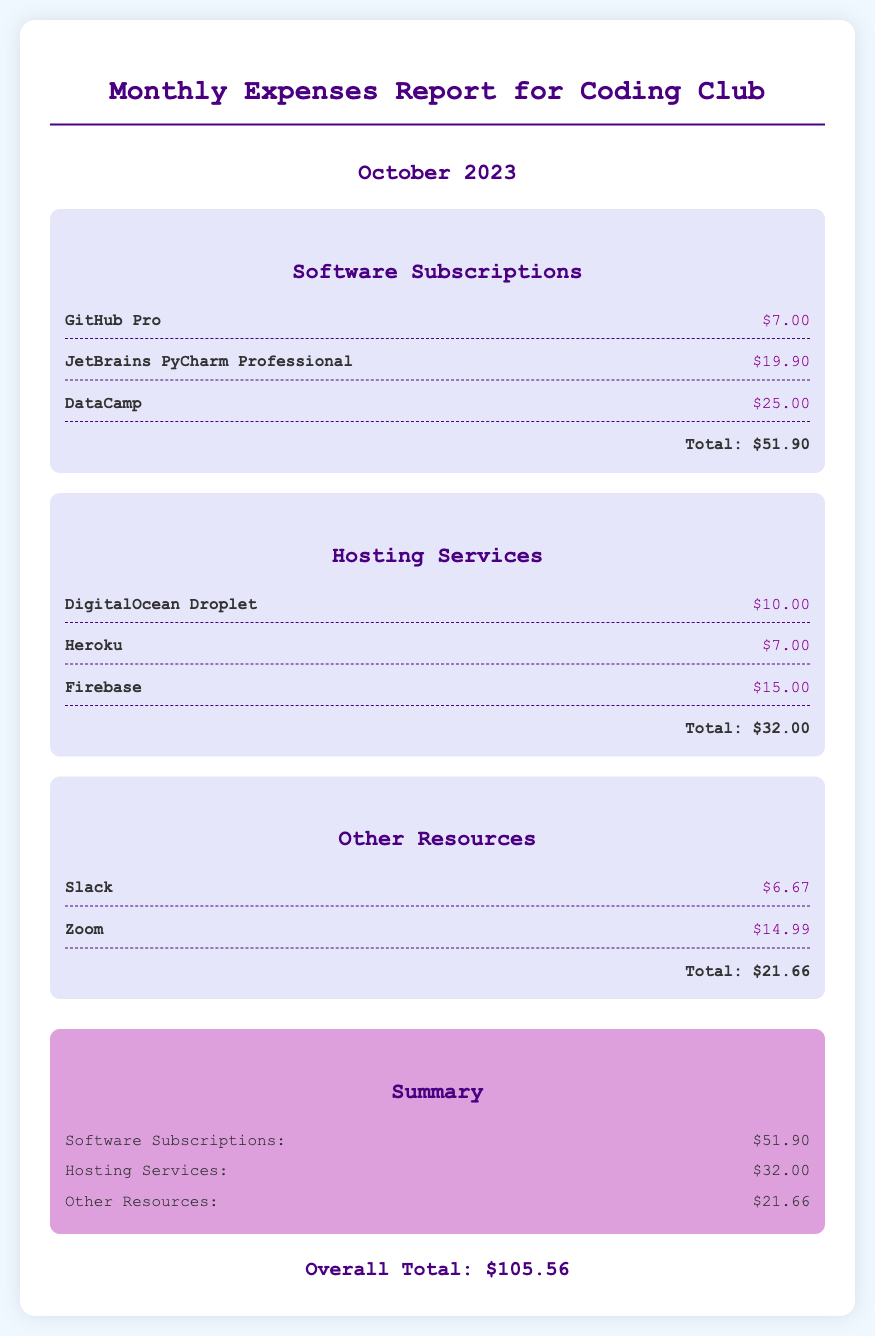What is the total cost for software subscriptions? The total cost for software subscriptions is listed at the bottom of the Software Subscriptions section in the document, which adds up to $51.90.
Answer: $51.90 How much does the DigitalOcean Droplet cost? The cost of the DigitalOcean Droplet is found in the Hosting Services section, where it is stated as $10.00.
Answer: $10.00 What is the overall total expense for October 2023? The overall total expense is the sum of all categories at the end of the document, which amounts to $105.56.
Answer: $105.56 Which software subscription has the highest cost? The highest cost among the software subscriptions is for JetBrains PyCharm Professional, shown in the Software Subscriptions section.
Answer: JetBrains PyCharm Professional What are the total expenses related to hosting services? The total expenses for hosting services are found at the end of the Hosting Services section, indicated as $32.00.
Answer: $32.00 How much does Zoom cost? The cost of Zoom is found under the Other Resources section, where it is specified as $14.99.
Answer: $14.99 What is the cost of the DataCamp subscription? The cost of DataCamp is included in the Software Subscriptions category, which is stated as $25.00.
Answer: $25.00 What is the total for other resources? The total for other resources is mentioned at the bottom of the Other Resources category, which amounts to $21.66.
Answer: $21.66 